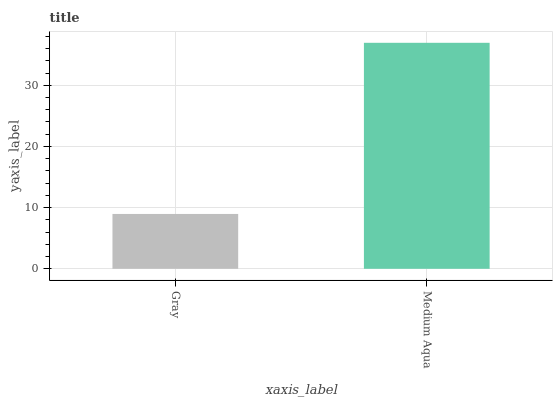Is Gray the minimum?
Answer yes or no. Yes. Is Medium Aqua the maximum?
Answer yes or no. Yes. Is Medium Aqua the minimum?
Answer yes or no. No. Is Medium Aqua greater than Gray?
Answer yes or no. Yes. Is Gray less than Medium Aqua?
Answer yes or no. Yes. Is Gray greater than Medium Aqua?
Answer yes or no. No. Is Medium Aqua less than Gray?
Answer yes or no. No. Is Medium Aqua the high median?
Answer yes or no. Yes. Is Gray the low median?
Answer yes or no. Yes. Is Gray the high median?
Answer yes or no. No. Is Medium Aqua the low median?
Answer yes or no. No. 